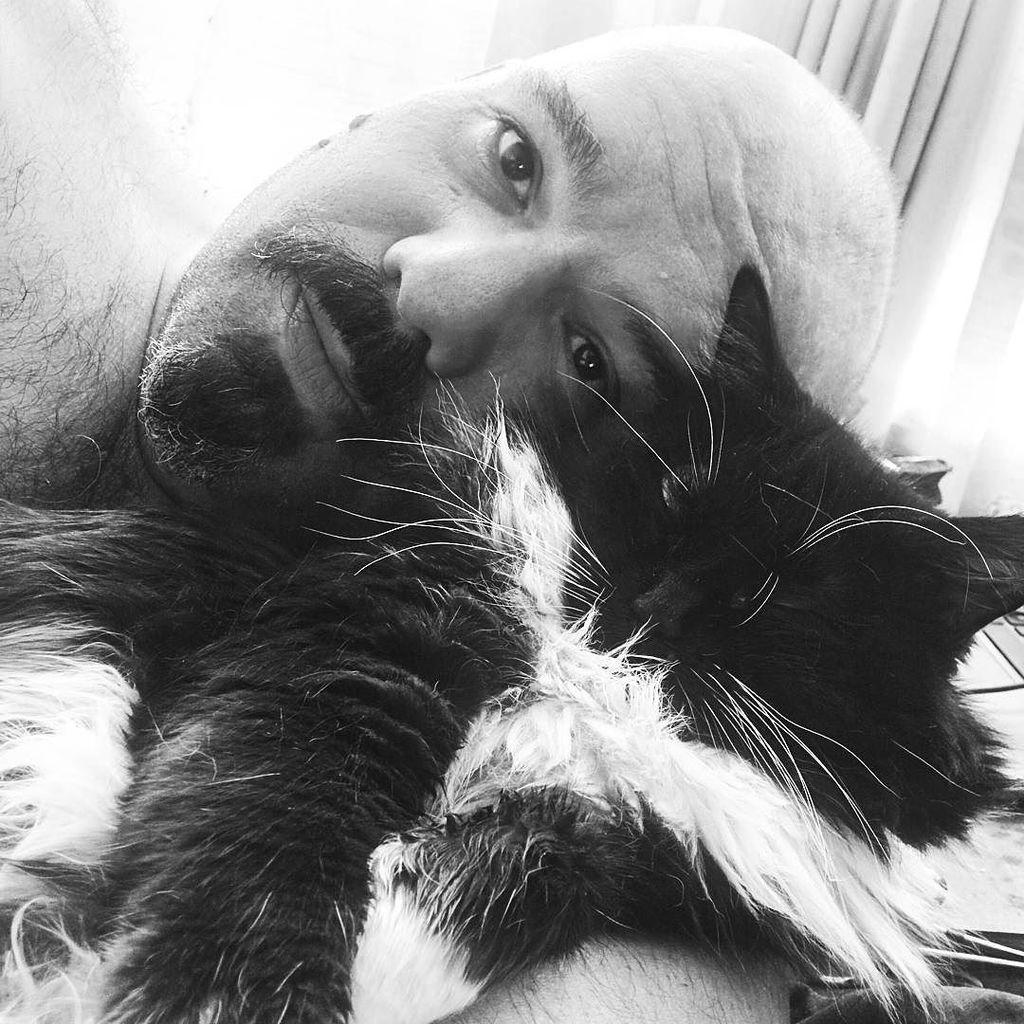What type of window treatment is visible in the image? There is a white color curtain in the image. Who is present in the image? There is a man in the image. What type of animal can be seen in the image? There is a black color cat in the image. How many ants are crawling on the man's shoulder in the image? There are no ants present in the image. What grade is the cat in the image? The cat is not a student, so it does not have a grade. 